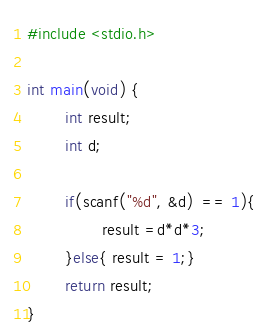Convert code to text. <code><loc_0><loc_0><loc_500><loc_500><_C_>#include <stdio.h>

int main(void) {
        int result;
        int d;

        if(scanf("%d", &d)  == 1){
                result =d*d*3;
        }else{ result = 1;}
        return result;
}</code> 